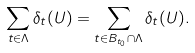<formula> <loc_0><loc_0><loc_500><loc_500>\sum _ { t \in \Lambda } \delta _ { t } ( U ) = \sum _ { t \in B _ { t _ { 0 } } \cap \Lambda } \delta _ { t } ( U ) .</formula> 